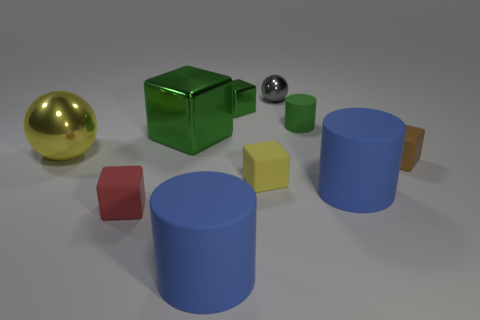Is there any other thing that is made of the same material as the small green cylinder?
Ensure brevity in your answer.  Yes. How many spheres are blue objects or shiny things?
Provide a short and direct response. 2. The block that is the same size as the yellow shiny ball is what color?
Provide a succinct answer. Green. What shape is the blue matte object on the right side of the ball to the right of the yellow matte object?
Keep it short and to the point. Cylinder. Does the metallic sphere in front of the gray sphere have the same size as the big cube?
Offer a very short reply. Yes. What number of other objects are there of the same material as the tiny gray object?
Give a very brief answer. 3. How many red things are either large metal cubes or small blocks?
Offer a very short reply. 1. What is the size of the thing that is the same color as the large metal ball?
Make the answer very short. Small. How many tiny things are in front of the big yellow ball?
Provide a succinct answer. 3. How big is the yellow object behind the yellow object in front of the tiny matte cube that is right of the yellow matte thing?
Keep it short and to the point. Large. 